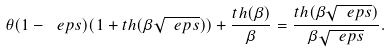Convert formula to latex. <formula><loc_0><loc_0><loc_500><loc_500>\theta ( 1 - \ e p s ) ( 1 + t h ( \beta \sqrt { \ e p s } ) ) + \frac { t h ( \beta ) } { \beta } = \frac { t h ( \beta \sqrt { \ e p s } ) } { \beta \sqrt { \ e p s } } .</formula> 